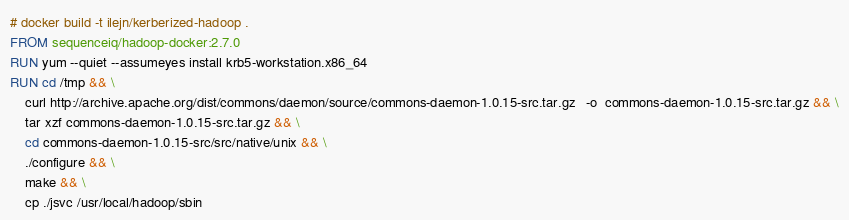Convert code to text. <code><loc_0><loc_0><loc_500><loc_500><_Dockerfile_># docker build -t ilejn/kerberized-hadoop .
FROM sequenceiq/hadoop-docker:2.7.0
RUN yum --quiet --assumeyes install krb5-workstation.x86_64
RUN cd /tmp && \
	curl http://archive.apache.org/dist/commons/daemon/source/commons-daemon-1.0.15-src.tar.gz   -o  commons-daemon-1.0.15-src.tar.gz && \
	tar xzf commons-daemon-1.0.15-src.tar.gz && \
	cd commons-daemon-1.0.15-src/src/native/unix && \
	./configure && \
	make && \
	cp ./jsvc /usr/local/hadoop/sbin
</code> 